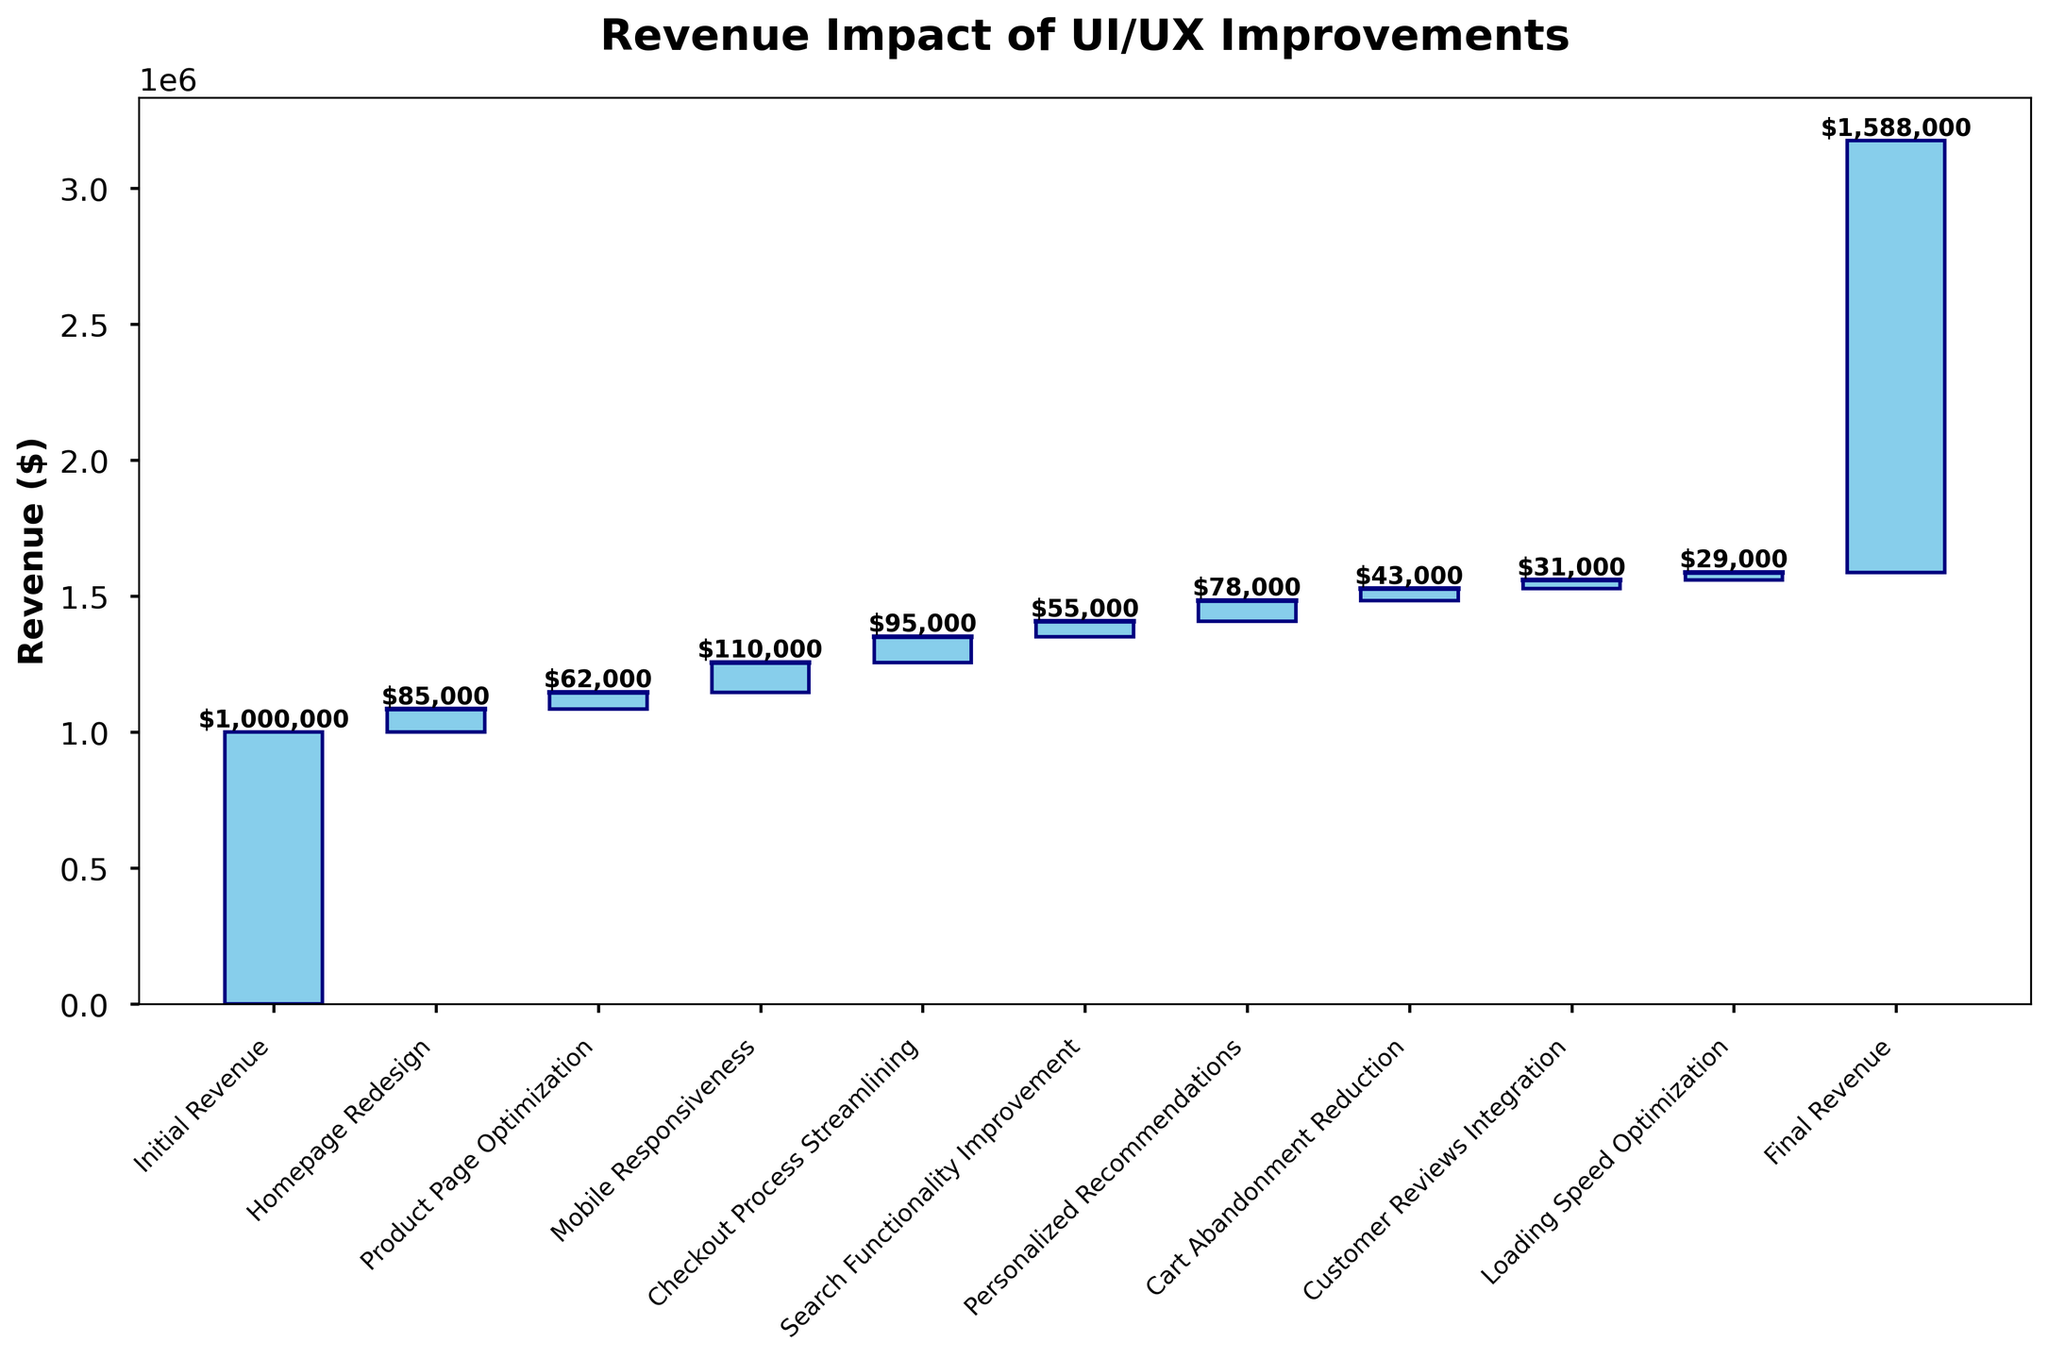how many categories are present in the figure? There are ten categories shown on the x-axis of the waterfall chart.
Answer: 10 What is the initial revenue shown in the figure? The initial revenue is clearly labeled on the first bar of the chart.
Answer: $1,000,000 Which UI/UX improvement had the largest impact on revenue? By looking at the height of each bar, the "Mobile Responsiveness" improvement had the tallest bar.
Answer: Mobile Responsiveness What was the total revenue gain from "Search Functionality Improvement" and "Personalized Recommendations"? The improvement gains are $55,000 and $78,000 respectively, summing them up gives $55,000 + $78,000 = $133,000
Answer: $133,000 How much did the revenue increase from "Product Page Optimization"? The height of the "Product Page Optimization" bar shows the revenue increment.
Answer: $62,000 How does the final revenue compare to the initial revenue? The final revenue is shown as $1,588,000 and the initial revenue was $1,000,000. The increase is $1,588,000 - $1,000,000 = $588,000
Answer: $588,000 Which improvement had a smaller revenue impact, "Customer Reviews Integration" or "Loading Speed Optimization"? Comparing the heights of these two bars shows that "Loading Speed Optimization" had a smaller impact than "Customer Reviews Integration".
Answer: Loading Speed Optimization What is the cumulative revenue after "Checkout Process Streamlining"? The cumulative revenue includes all improvements up to and including "Checkout Process Streamlining". Adding up all values: $1,000,000 initial + $85,000 homepage redesign + $62,000 product page + $110,000 mobile + $95,000 checkout = $1,352,000
Answer: $1,352,000 What is the revenue impact difference between "Homepage Redesign" and "Cart Abandonment Reduction"? The revenue impact from "Homepage Redesign" is $85,000, and from "Cart Abandonment Reduction" is $43,000. The difference is $85,000 - $43,000 = $42,000
Answer: $42,000 